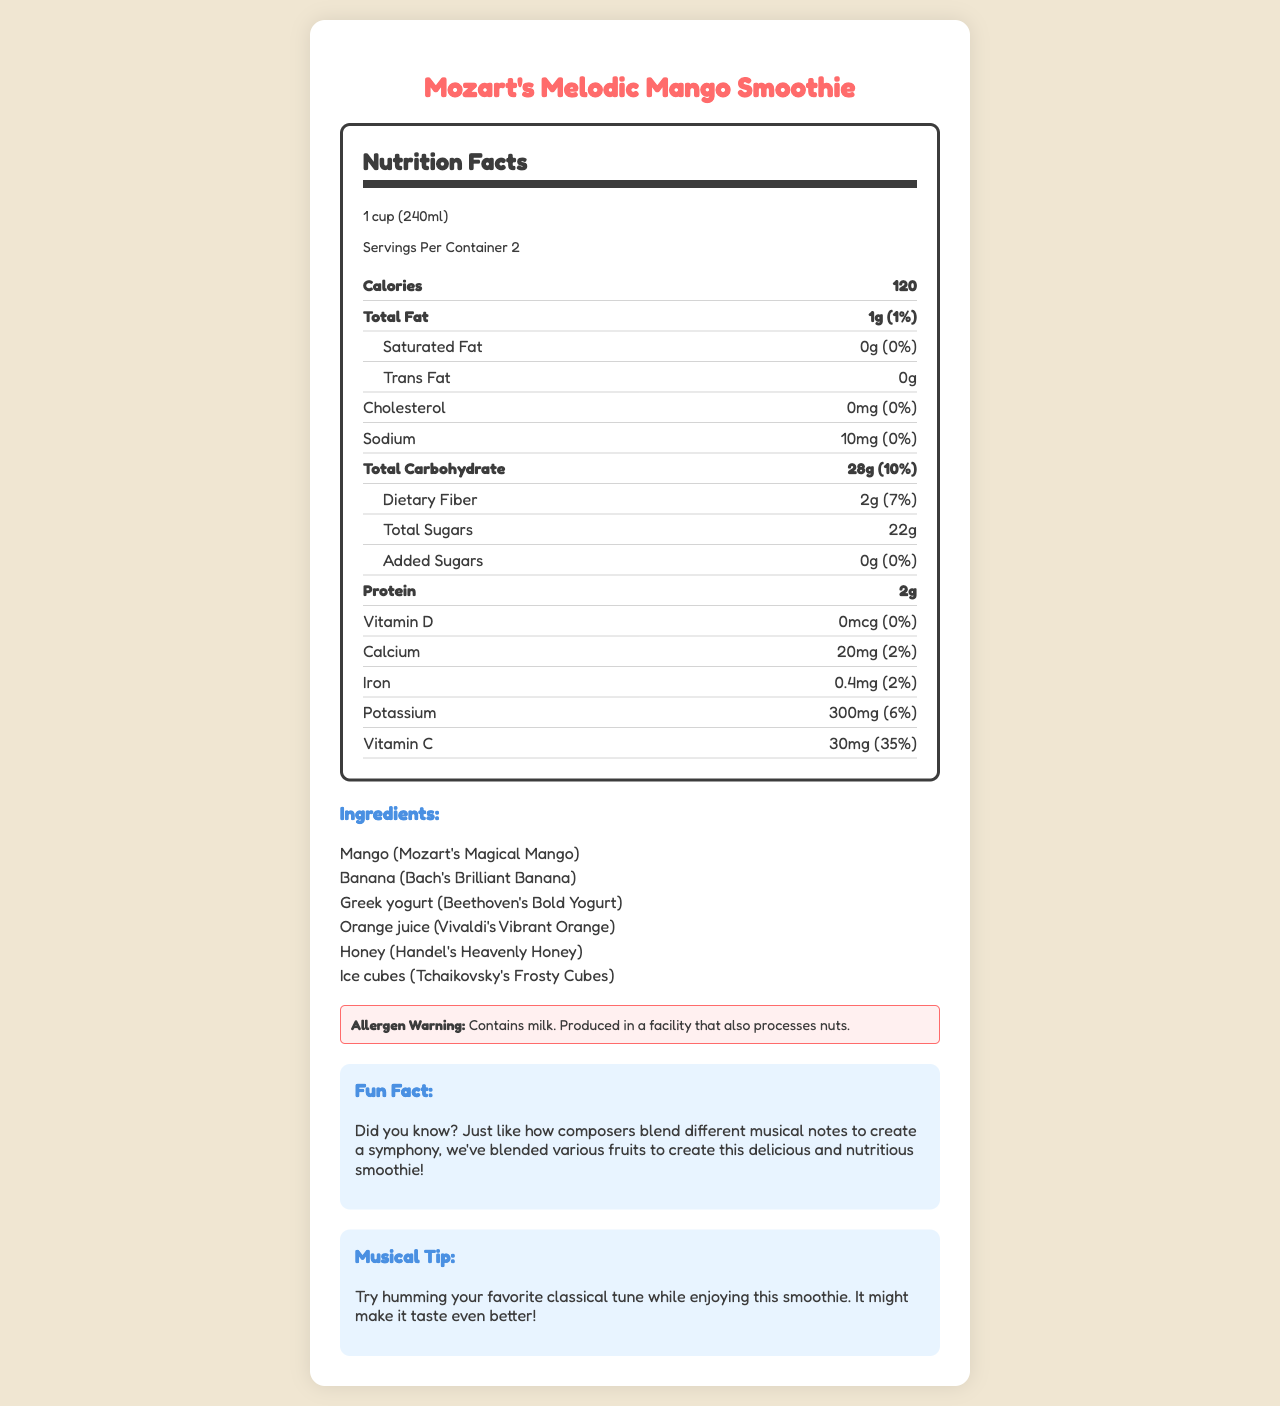what is the serving size for Mozart's Melodic Mango Smoothie? The serving size is clearly listed as "1 cup (240ml)" in the document.
Answer: 1 cup (240ml) how many servings are there per container? The document states there are 2 servings per container.
Answer: 2 how many calories are in one serving? The number of calories per serving is specified as 120.
Answer: 120 what allergens are present in this smoothie? The allergen warning section indicates the smoothie contains milk.
Answer: Milk how much vitamin C is in one serving? The amount of vitamin C per serving is listed as 30mg, which is 35% of the daily value.
Answer: 30mg how much total fat is in this smoothie? A. 1g B. 5g C. 10g D. 20g The total fat amount per serving is 1g as indicated under the "Total Fat" section.
Answer: A. 1g which ingredient corresponds with Beethoven? A. Mango B. Banana C. Greek yogurt D. Orange juice In the ingredients list, Greek yogurt is named "Beethoven's Bold Yogurt".
Answer: C. Greek yogurt does this smoothie contain any added sugars? Yes/No The nutrition facts label shows that added sugars are 0g, which means no added sugars.
Answer: No summarize the main topics covered in this document. The document provides detailed nutritional information like calories, fats, vitamins, etc., a list of ingredients with composer-themed names, an allergen warning, a fun fact about the smoothie, and a musical tip.
Answer: The document details the nutrition facts, ingredients, allergen warnings, and some fun facts and tips related to Mozart's Melodic Mango Smoothie. what is the amount of potassium in the smoothie? The potassium content is listed as 300mg per serving.
Answer: 300mg what is the total amount of sugars in one serving? The document lists the total sugars as 22g.
Answer: 22g what percent of the daily value of dietary fiber is in one serving? The dietary fiber is listed as providing 7% of the daily value.
Answer: 7% is this smoothie high in sodium? The sodium content is only 10mg, which is 0% of the daily value, indicating it is not high in sodium.
Answer: No who is the smoothie named after? The product name is "Mozart's Melodic Mango Smoothie", indicating it is named after Mozart.
Answer: Mozart how much vitamin D is in the smoothie? The vitamin D content is listed as 0mcg.
Answer: 0mcg what is the combined total of both protein and dietary fiber in one serving? The document states there are 2g of protein and 2g of dietary fiber in one serving, making a combined total of 4g.
Answer: 4g how many grams of calcium does this smoothie contain? The amount of calcium is given in milligrams (20mg), but the question asks for grams, which would require conversion.
Answer: Not enough information 